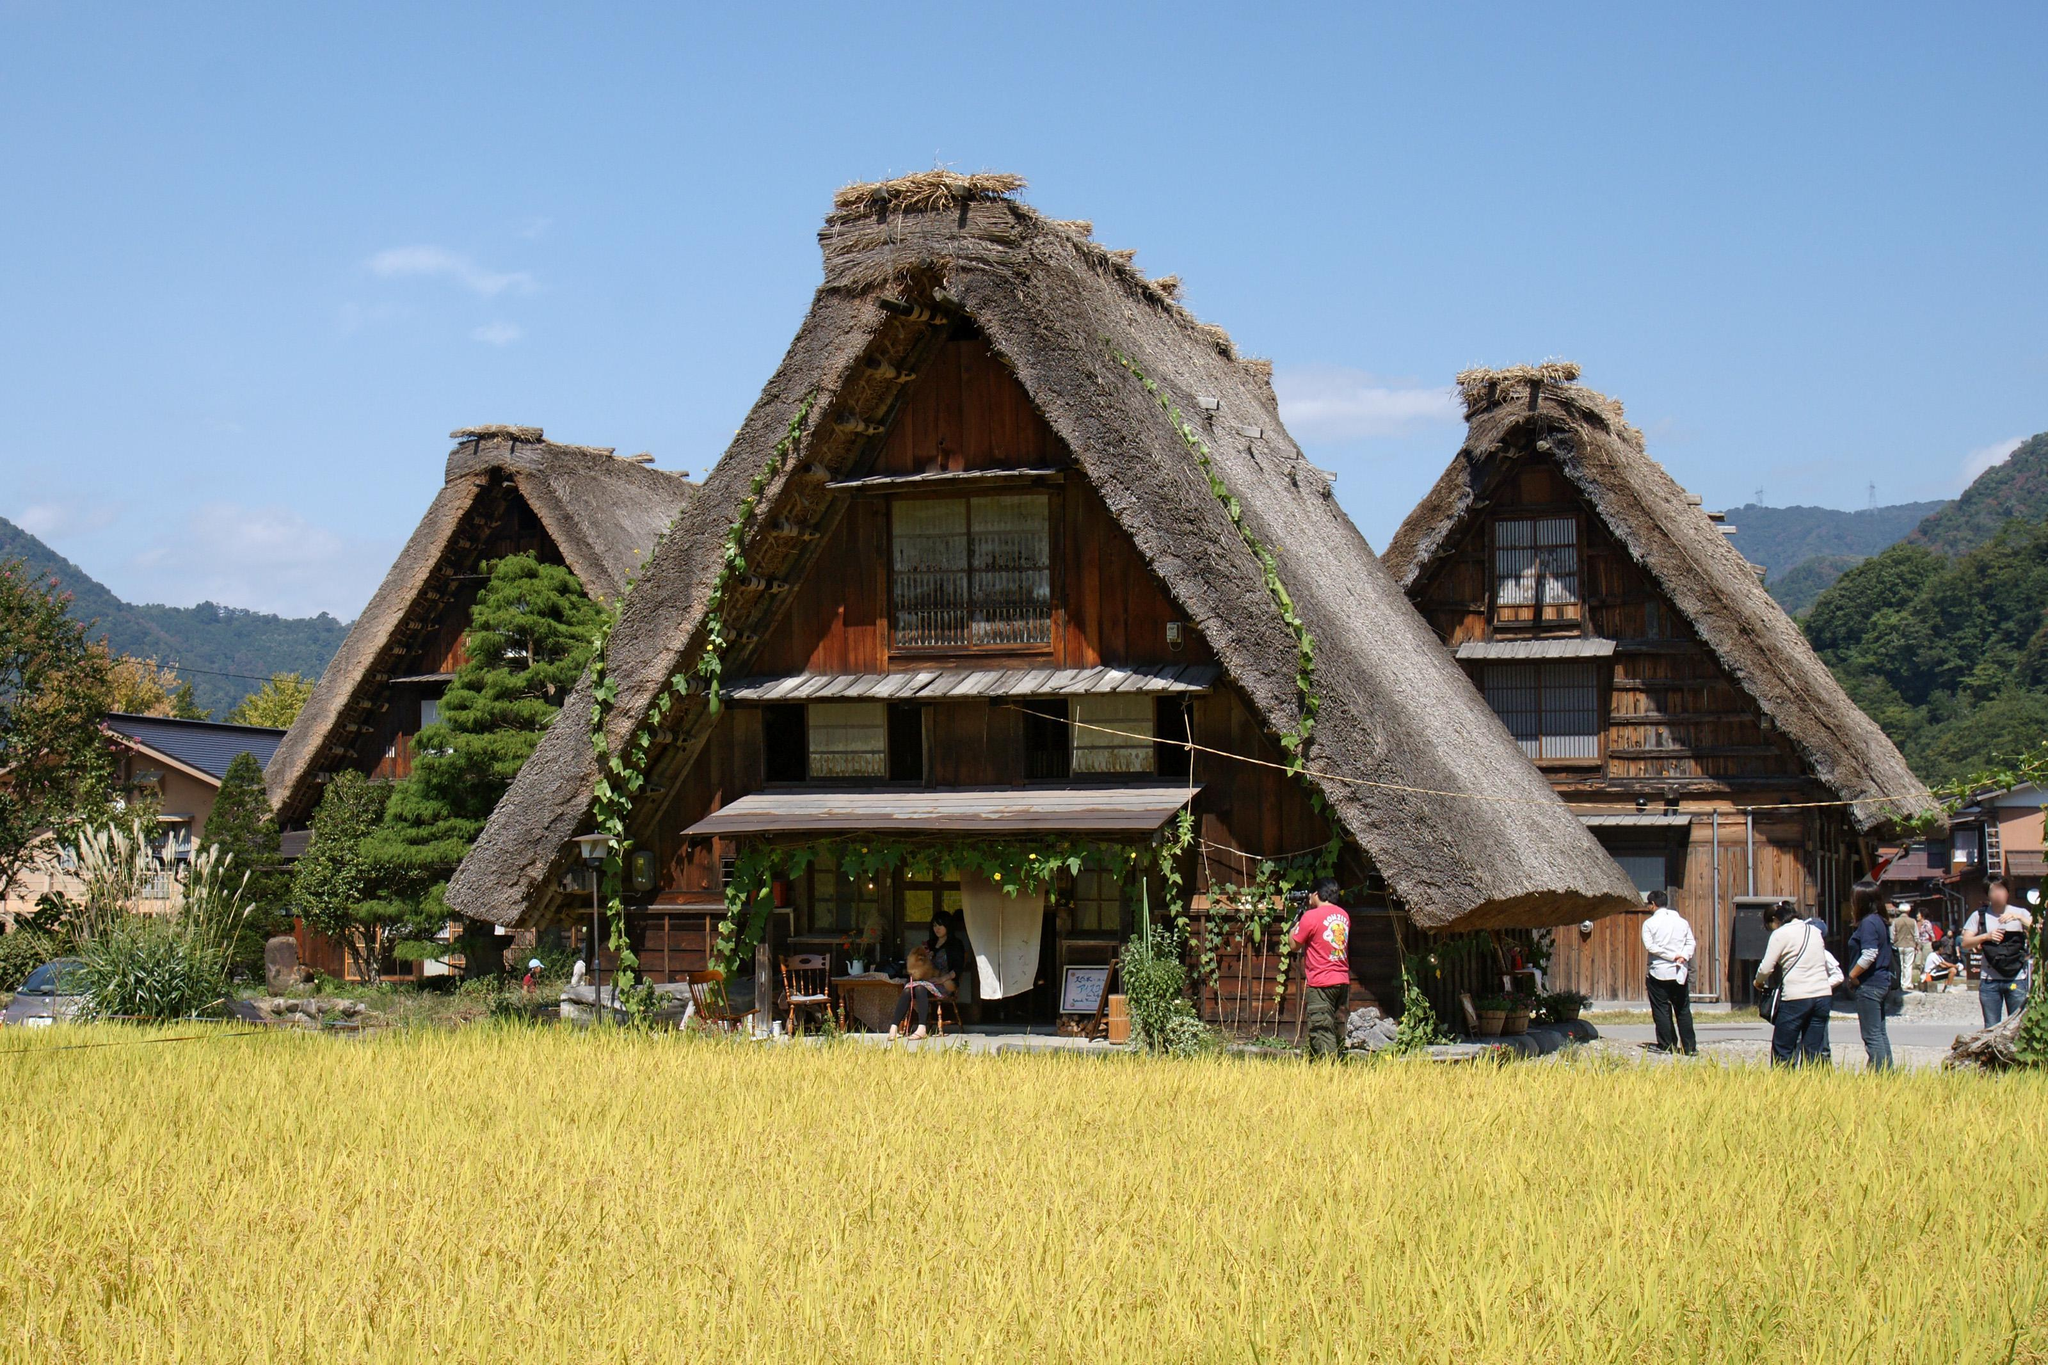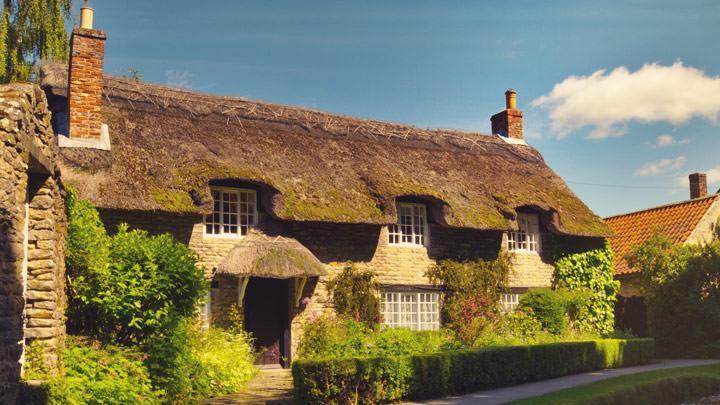The first image is the image on the left, the second image is the image on the right. Considering the images on both sides, is "In at least one image there is a house with only one chimney on the right side." valid? Answer yes or no. No. The first image is the image on the left, the second image is the image on the right. Given the left and right images, does the statement "At least two humans are visible." hold true? Answer yes or no. Yes. 